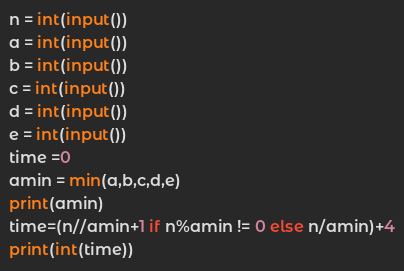<code> <loc_0><loc_0><loc_500><loc_500><_Python_>n = int(input())
a = int(input())
b = int(input())
c = int(input())
d = int(input())
e = int(input())
time =0
amin = min(a,b,c,d,e)
print(amin)
time=(n//amin+1 if n%amin != 0 else n/amin)+4
print(int(time))</code> 